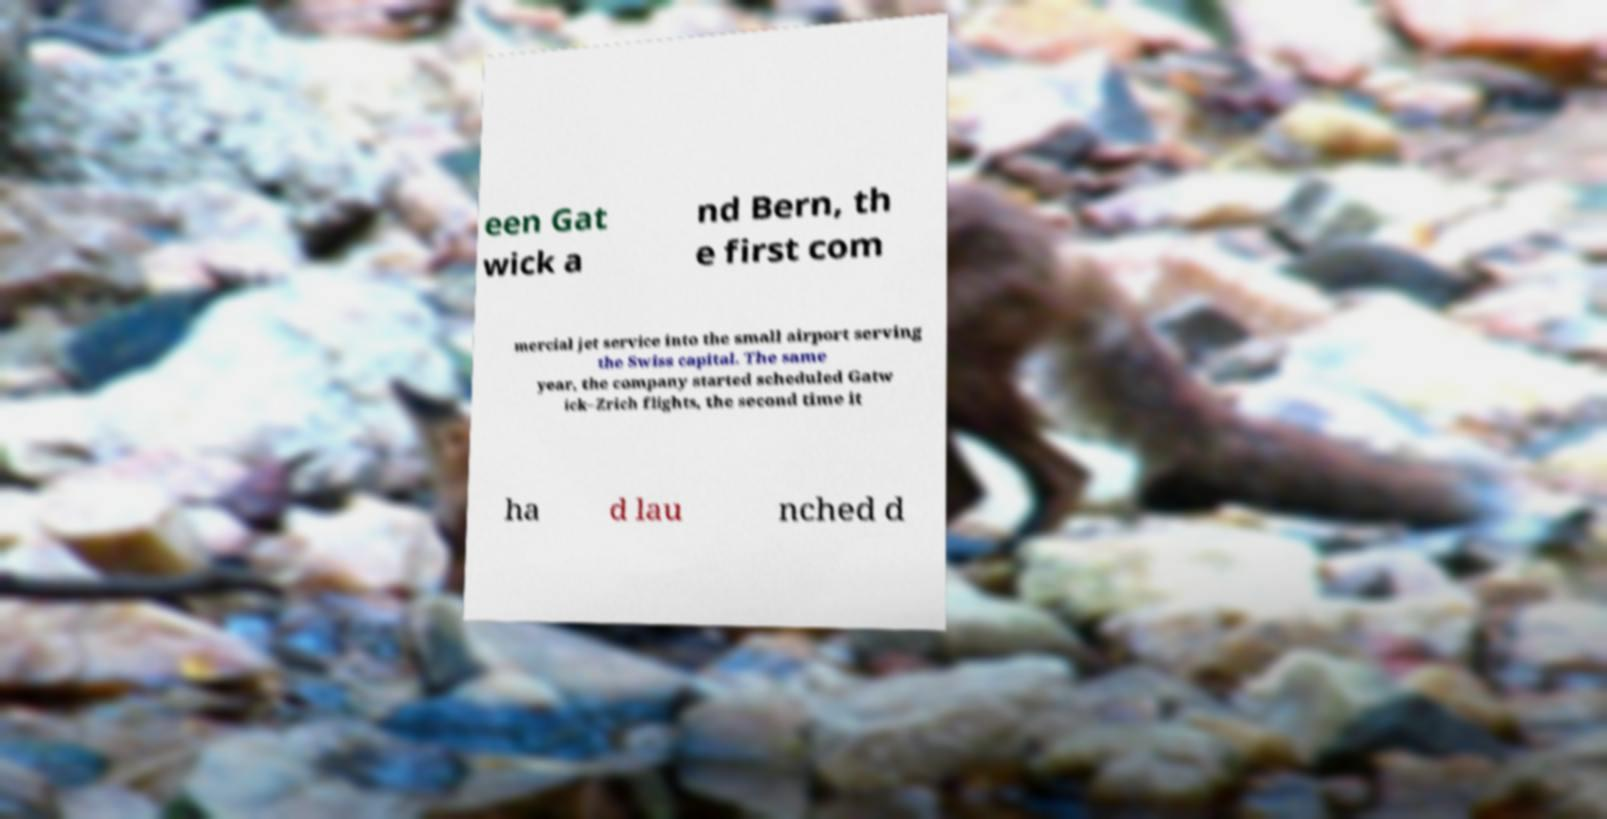There's text embedded in this image that I need extracted. Can you transcribe it verbatim? een Gat wick a nd Bern, th e first com mercial jet service into the small airport serving the Swiss capital. The same year, the company started scheduled Gatw ick–Zrich flights, the second time it ha d lau nched d 